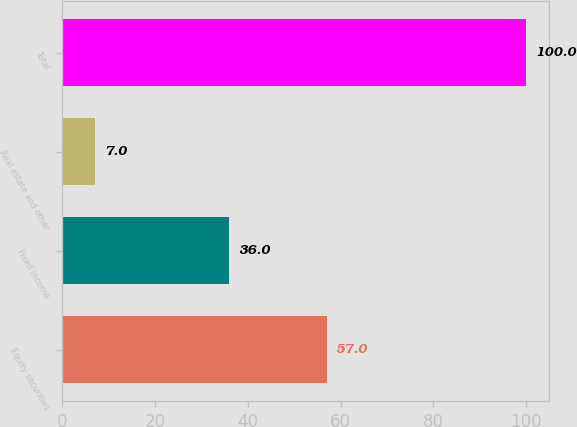<chart> <loc_0><loc_0><loc_500><loc_500><bar_chart><fcel>Equity securities<fcel>Fixed income<fcel>Real estate and other<fcel>Total<nl><fcel>57<fcel>36<fcel>7<fcel>100<nl></chart> 